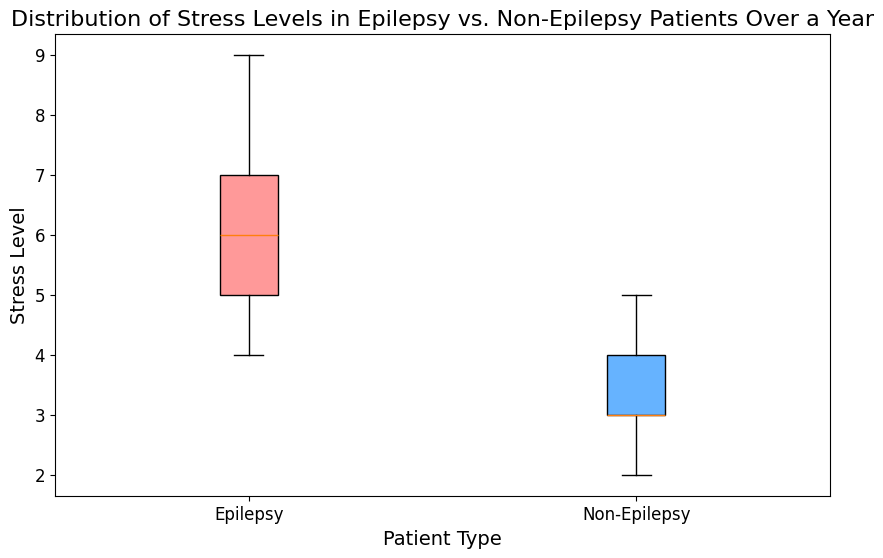Which group has a higher median stress level? Examine the central line (median) in both box plots. The median line in the 'Epilepsy' group is higher than the one in the 'Non-Epilepsy' group.
Answer: Epilepsy What's the range of stress levels in the Epilepsy group? The range is determined by the difference between the maximum (upper whisker) and minimum (lower whisker) values in the box plot for the Epilepsy group. Both the maximum and minimum values are visible at the ends of the whiskers.
Answer: 9 - 4 = 5 Comparing the interquartile range (IQR) of both groups, which one has a larger IQR? Locate the upper quartile (top of the box) and lower quartile (bottom of the box) for both groups, then compare the distance between these quartiles. The 'Epilepsy' group has a larger IQR than the 'Non-Epilepsy' group.
Answer: Epilepsy What is the upper quartile value for the Non-Epilepsy group? The upper quartile (third quartile) for a box plot is the top edge of the box in the 'Non-Epilepsy' group plot.
Answer: 4 How do the median stress levels compare between the two groups? The median values are the central lines in the boxes for each group. The median stress level in the 'Epilepsy' group is higher compared to the 'Non-Epilepsy' group.
Answer: Epilepsy has a higher median What is the maximum reported stress level for Non-Epilepsy patients? The maximum value for 'Non-Epilepsy' patients is represented by the upper whisker of its box plot.
Answer: 5 Is the spread of stress levels wider in the Epilepsy group or the Non-Epilepsy group? The spread is determined by the length of the whiskers and the box. The 'Epilepsy' group has a wider spread than the 'Non-Epilepsy' group.
Answer: Epilepsy What is the difference between the medians of the two groups? Identify the median value for both groups and subtract the median of the 'Non-Epilepsy' group from the median of the 'Epilepsy' group.
Answer: 6 - 3 = 3 Does either group have any potential outliers? Outliers are typically represented as individual points outside of the whiskers in a box plot. Check for any isolated points beyond the whiskers in the plots.
Answer: No 